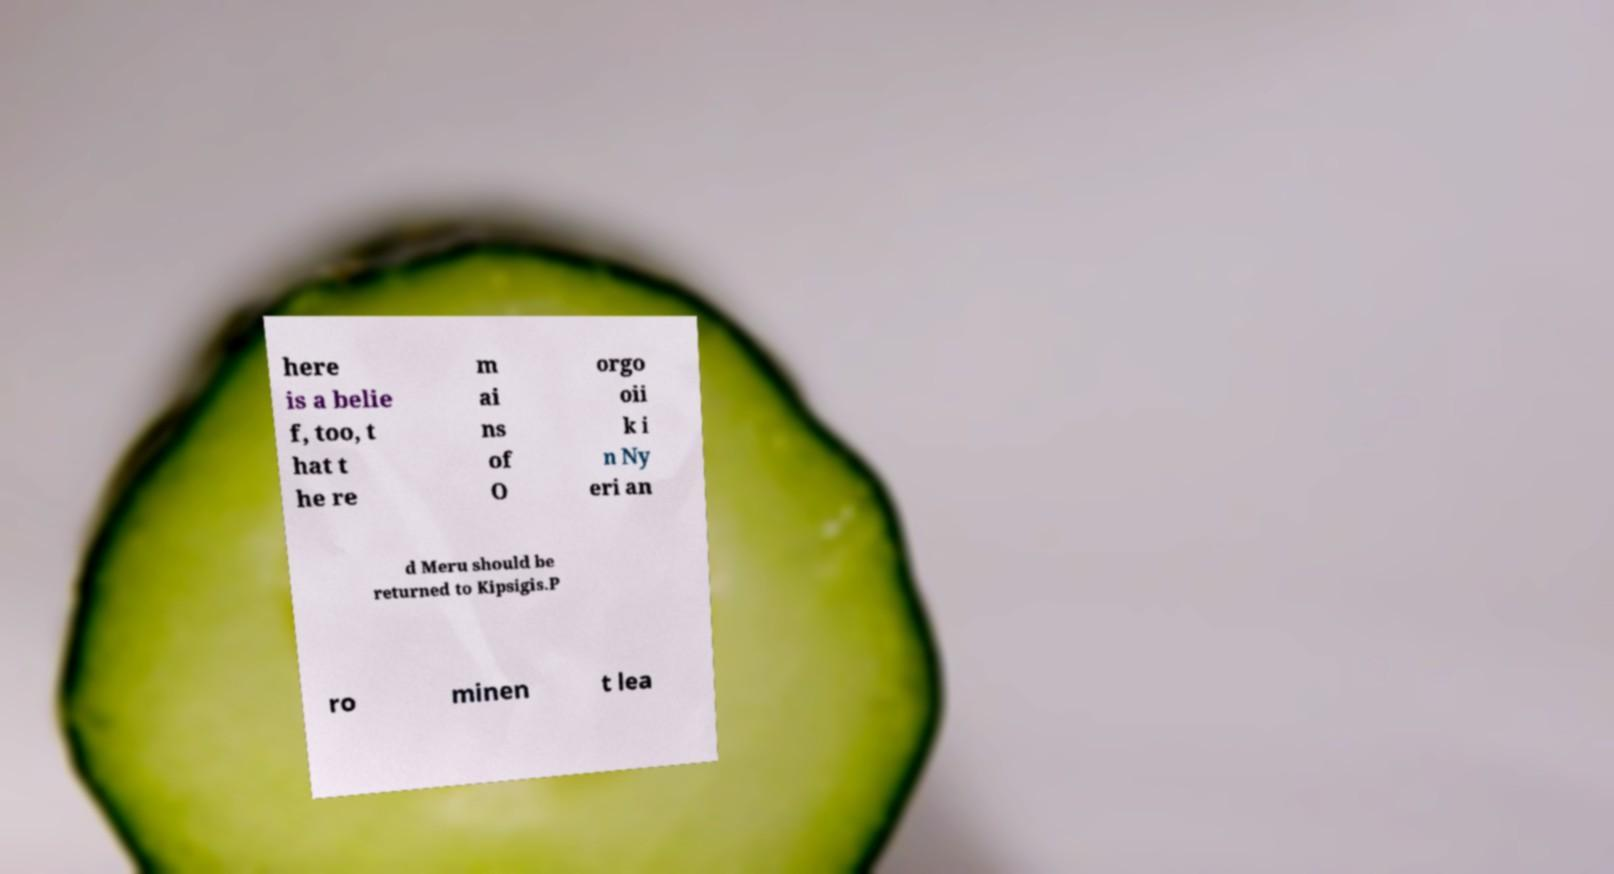For documentation purposes, I need the text within this image transcribed. Could you provide that? here is a belie f, too, t hat t he re m ai ns of O orgo oii k i n Ny eri an d Meru should be returned to Kipsigis.P ro minen t lea 